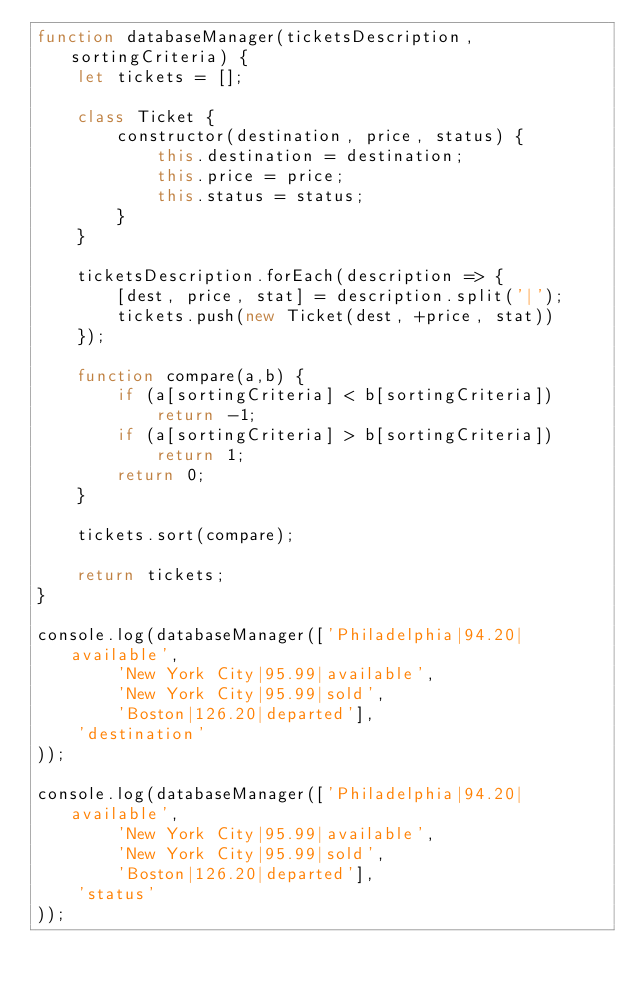<code> <loc_0><loc_0><loc_500><loc_500><_JavaScript_>function databaseManager(ticketsDescription, sortingCriteria) {
    let tickets = [];

    class Ticket {
        constructor(destination, price, status) {
            this.destination = destination;
            this.price = price;
            this.status = status;
        }
    }

    ticketsDescription.forEach(description => {
        [dest, price, stat] = description.split('|');
        tickets.push(new Ticket(dest, +price, stat))
    });

    function compare(a,b) {
        if (a[sortingCriteria] < b[sortingCriteria])
            return -1;
        if (a[sortingCriteria] > b[sortingCriteria])
            return 1;
        return 0;
    }

    tickets.sort(compare);

    return tickets;
}

console.log(databaseManager(['Philadelphia|94.20|available',
        'New York City|95.99|available',
        'New York City|95.99|sold',
        'Boston|126.20|departed'],
    'destination'
));

console.log(databaseManager(['Philadelphia|94.20|available',
        'New York City|95.99|available',
        'New York City|95.99|sold',
        'Boston|126.20|departed'],
    'status'
));</code> 